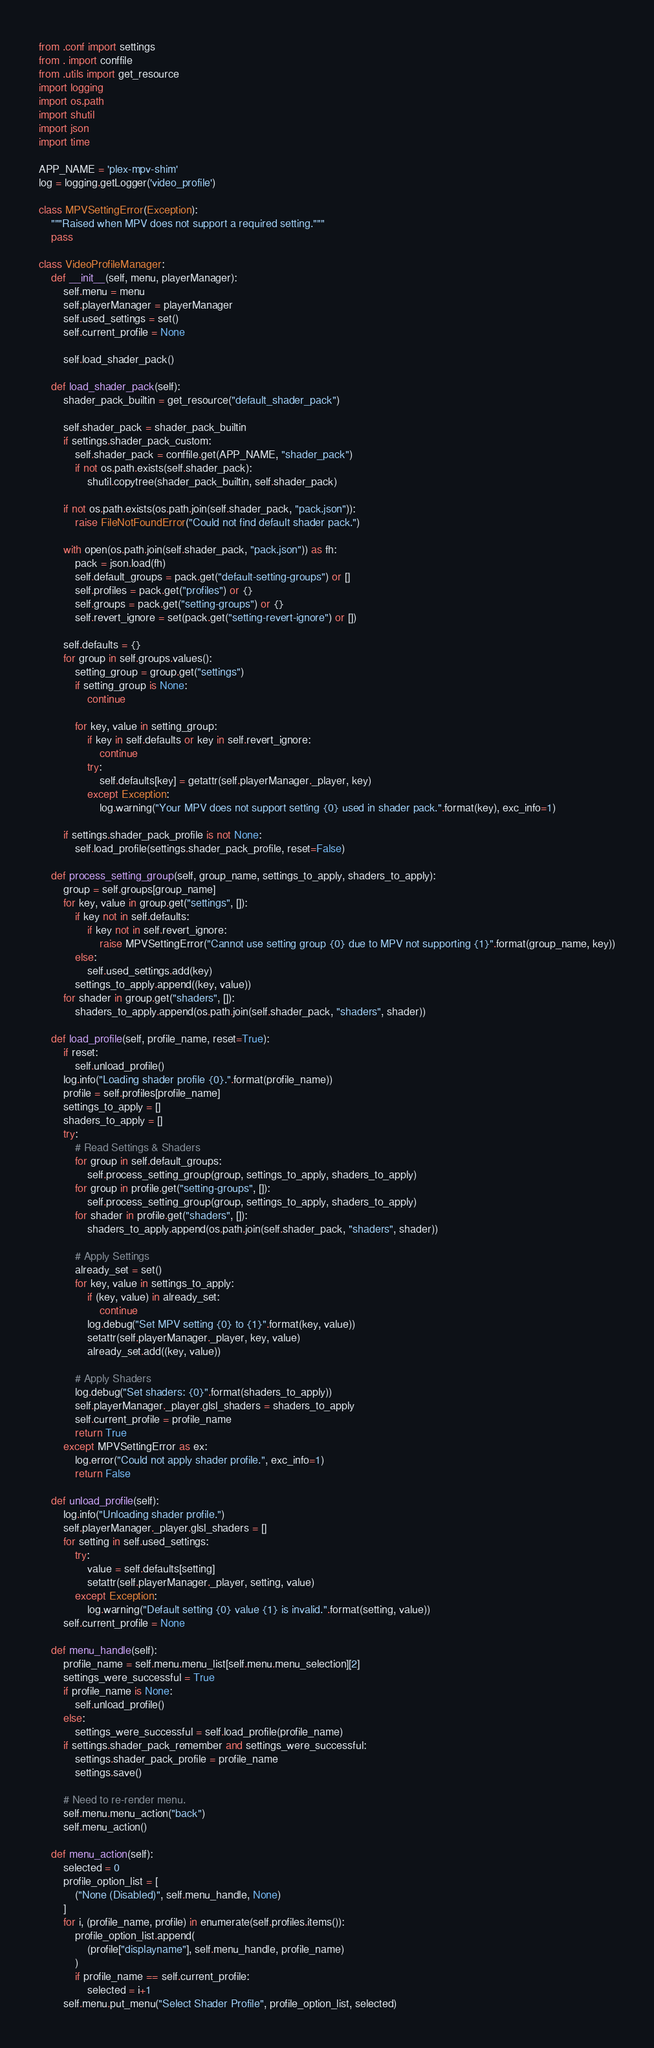Convert code to text. <code><loc_0><loc_0><loc_500><loc_500><_Python_>from .conf import settings
from . import conffile
from .utils import get_resource
import logging
import os.path
import shutil
import json
import time

APP_NAME = 'plex-mpv-shim'
log = logging.getLogger('video_profile')

class MPVSettingError(Exception):
    """Raised when MPV does not support a required setting."""
    pass

class VideoProfileManager:
    def __init__(self, menu, playerManager):
        self.menu = menu
        self.playerManager = playerManager
        self.used_settings = set()
        self.current_profile = None

        self.load_shader_pack()
    
    def load_shader_pack(self):
        shader_pack_builtin = get_resource("default_shader_pack")

        self.shader_pack = shader_pack_builtin
        if settings.shader_pack_custom:
            self.shader_pack = conffile.get(APP_NAME, "shader_pack")
            if not os.path.exists(self.shader_pack):
                shutil.copytree(shader_pack_builtin, self.shader_pack)
        
        if not os.path.exists(os.path.join(self.shader_pack, "pack.json")):
            raise FileNotFoundError("Could not find default shader pack.")

        with open(os.path.join(self.shader_pack, "pack.json")) as fh:
            pack = json.load(fh)
            self.default_groups = pack.get("default-setting-groups") or []
            self.profiles = pack.get("profiles") or {}
            self.groups = pack.get("setting-groups") or {}
            self.revert_ignore = set(pack.get("setting-revert-ignore") or [])

        self.defaults = {}
        for group in self.groups.values():
            setting_group = group.get("settings")
            if setting_group is None:
                continue

            for key, value in setting_group:
                if key in self.defaults or key in self.revert_ignore:
                    continue
                try:
                    self.defaults[key] = getattr(self.playerManager._player, key)
                except Exception:
                    log.warning("Your MPV does not support setting {0} used in shader pack.".format(key), exc_info=1)

        if settings.shader_pack_profile is not None:
            self.load_profile(settings.shader_pack_profile, reset=False)

    def process_setting_group(self, group_name, settings_to_apply, shaders_to_apply):
        group = self.groups[group_name]
        for key, value in group.get("settings", []):
            if key not in self.defaults:
                if key not in self.revert_ignore:
                    raise MPVSettingError("Cannot use setting group {0} due to MPV not supporting {1}".format(group_name, key))
            else:
                self.used_settings.add(key)
            settings_to_apply.append((key, value))
        for shader in group.get("shaders", []):
            shaders_to_apply.append(os.path.join(self.shader_pack, "shaders", shader))

    def load_profile(self, profile_name, reset=True):
        if reset:
            self.unload_profile()
        log.info("Loading shader profile {0}.".format(profile_name))
        profile = self.profiles[profile_name]
        settings_to_apply = []
        shaders_to_apply = []
        try:
            # Read Settings & Shaders
            for group in self.default_groups:
                self.process_setting_group(group, settings_to_apply, shaders_to_apply)
            for group in profile.get("setting-groups", []):
                self.process_setting_group(group, settings_to_apply, shaders_to_apply)
            for shader in profile.get("shaders", []):
                shaders_to_apply.append(os.path.join(self.shader_pack, "shaders", shader))

            # Apply Settings
            already_set = set()
            for key, value in settings_to_apply:
                if (key, value) in already_set:
                    continue
                log.debug("Set MPV setting {0} to {1}".format(key, value))
                setattr(self.playerManager._player, key, value)
                already_set.add((key, value))

            # Apply Shaders
            log.debug("Set shaders: {0}".format(shaders_to_apply))
            self.playerManager._player.glsl_shaders = shaders_to_apply
            self.current_profile = profile_name
            return True
        except MPVSettingError as ex:
            log.error("Could not apply shader profile.", exc_info=1)
            return False

    def unload_profile(self):
        log.info("Unloading shader profile.")
        self.playerManager._player.glsl_shaders = []
        for setting in self.used_settings:
            try:
                value = self.defaults[setting]
                setattr(self.playerManager._player, setting, value)
            except Exception:
                log.warning("Default setting {0} value {1} is invalid.".format(setting, value))
        self.current_profile = None

    def menu_handle(self):
        profile_name = self.menu.menu_list[self.menu.menu_selection][2]
        settings_were_successful = True
        if profile_name is None:
            self.unload_profile()
        else:
            settings_were_successful = self.load_profile(profile_name)
        if settings.shader_pack_remember and settings_were_successful:
            settings.shader_pack_profile = profile_name
            settings.save()
        
        # Need to re-render menu.
        self.menu.menu_action("back")
        self.menu_action()

    def menu_action(self):
        selected = 0
        profile_option_list = [
            ("None (Disabled)", self.menu_handle, None)
        ]
        for i, (profile_name, profile) in enumerate(self.profiles.items()):
            profile_option_list.append(
                (profile["displayname"], self.menu_handle, profile_name)
            )
            if profile_name == self.current_profile:
                selected = i+1
        self.menu.put_menu("Select Shader Profile", profile_option_list, selected)
</code> 